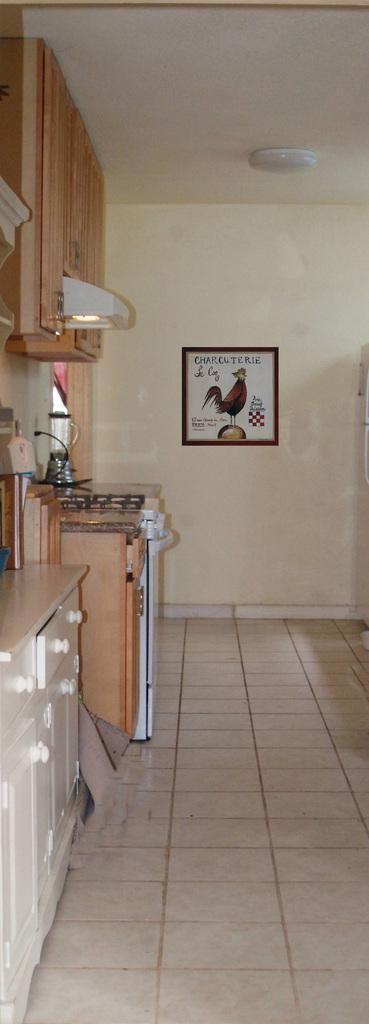Could you give a brief overview of what you see in this image? This is inside view of a room. On the left side we can see cupboards, drawer, chimney and objects. In the background we can see frame on the wall and light on the ceiling. 